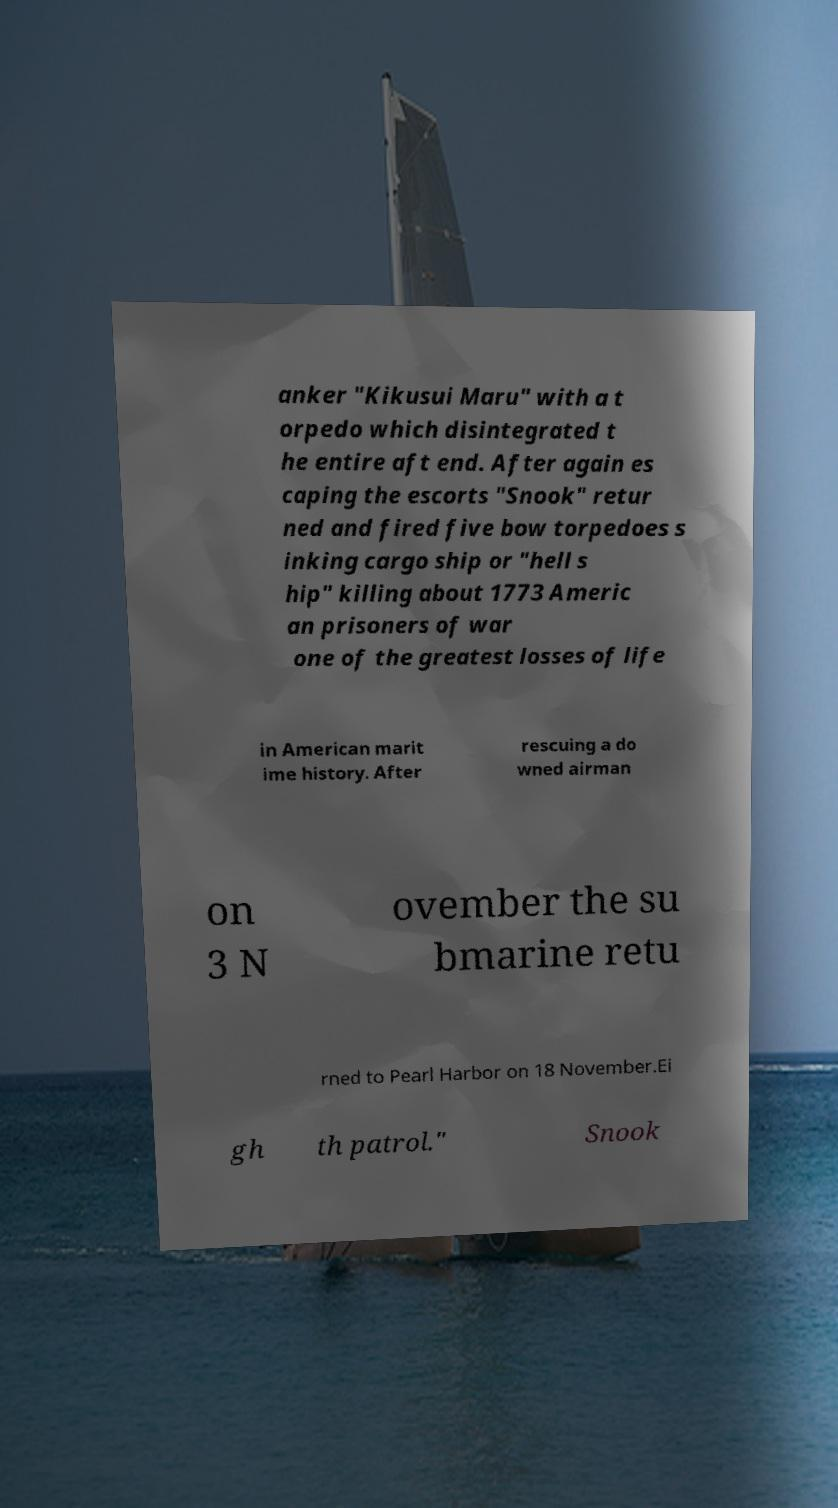What messages or text are displayed in this image? I need them in a readable, typed format. anker "Kikusui Maru" with a t orpedo which disintegrated t he entire aft end. After again es caping the escorts "Snook" retur ned and fired five bow torpedoes s inking cargo ship or "hell s hip" killing about 1773 Americ an prisoners of war one of the greatest losses of life in American marit ime history. After rescuing a do wned airman on 3 N ovember the su bmarine retu rned to Pearl Harbor on 18 November.Ei gh th patrol." Snook 